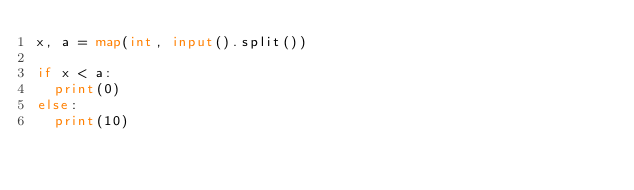<code> <loc_0><loc_0><loc_500><loc_500><_Python_>x, a = map(int, input().split())

if x < a:
  print(0)
else:
  print(10)</code> 